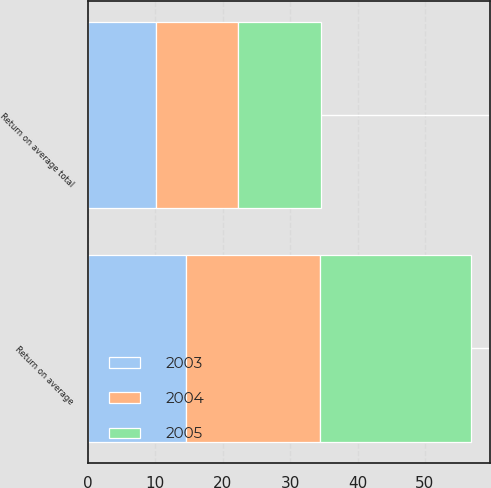Convert chart. <chart><loc_0><loc_0><loc_500><loc_500><stacked_bar_chart><ecel><fcel>Return on average<fcel>Return on average total<nl><fcel>2003<fcel>14.6<fcel>10.1<nl><fcel>2004<fcel>19.9<fcel>12.1<nl><fcel>2005<fcel>22.3<fcel>12.4<nl></chart> 